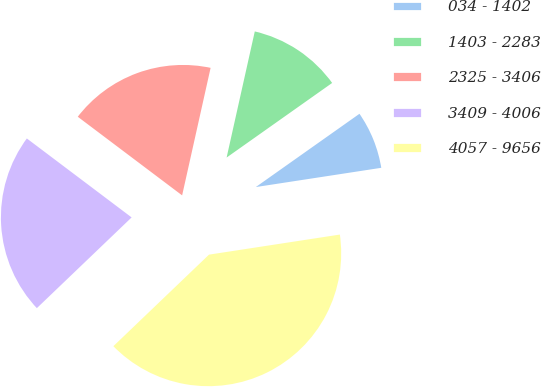Convert chart. <chart><loc_0><loc_0><loc_500><loc_500><pie_chart><fcel>034 - 1402<fcel>1403 - 2283<fcel>2325 - 3406<fcel>3409 - 4006<fcel>4057 - 9656<nl><fcel>7.37%<fcel>11.71%<fcel>18.22%<fcel>22.43%<fcel>40.27%<nl></chart> 